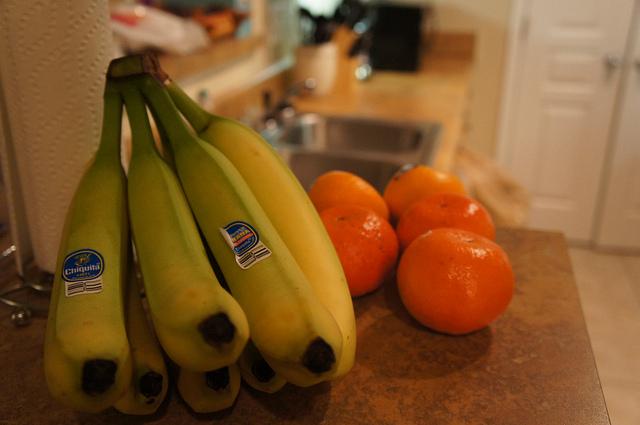Is there more than one tomato on the table?
Concise answer only. No. What kind of fruit is this?
Keep it brief. Banana and orange. What is on the banana stem?
Keep it brief. Bananas. What food is in this picture?
Write a very short answer. Fruit. What other fruit is visible besides bananas?
Give a very brief answer. Oranges. Is this indoors?
Quick response, please. Yes. What brand is the banana?
Write a very short answer. Chiquita. How many bananas are there?
Concise answer only. 7. Are the bananas ripe?
Concise answer only. No. What room is this?
Give a very brief answer. Kitchen. Are the bananas drawn on?
Give a very brief answer. No. Is the sticker funny?
Be succinct. No. Is there any metal in this picture?
Concise answer only. No. Are these items for sale?
Give a very brief answer. No. Is this fruit edible?
Write a very short answer. Yes. 